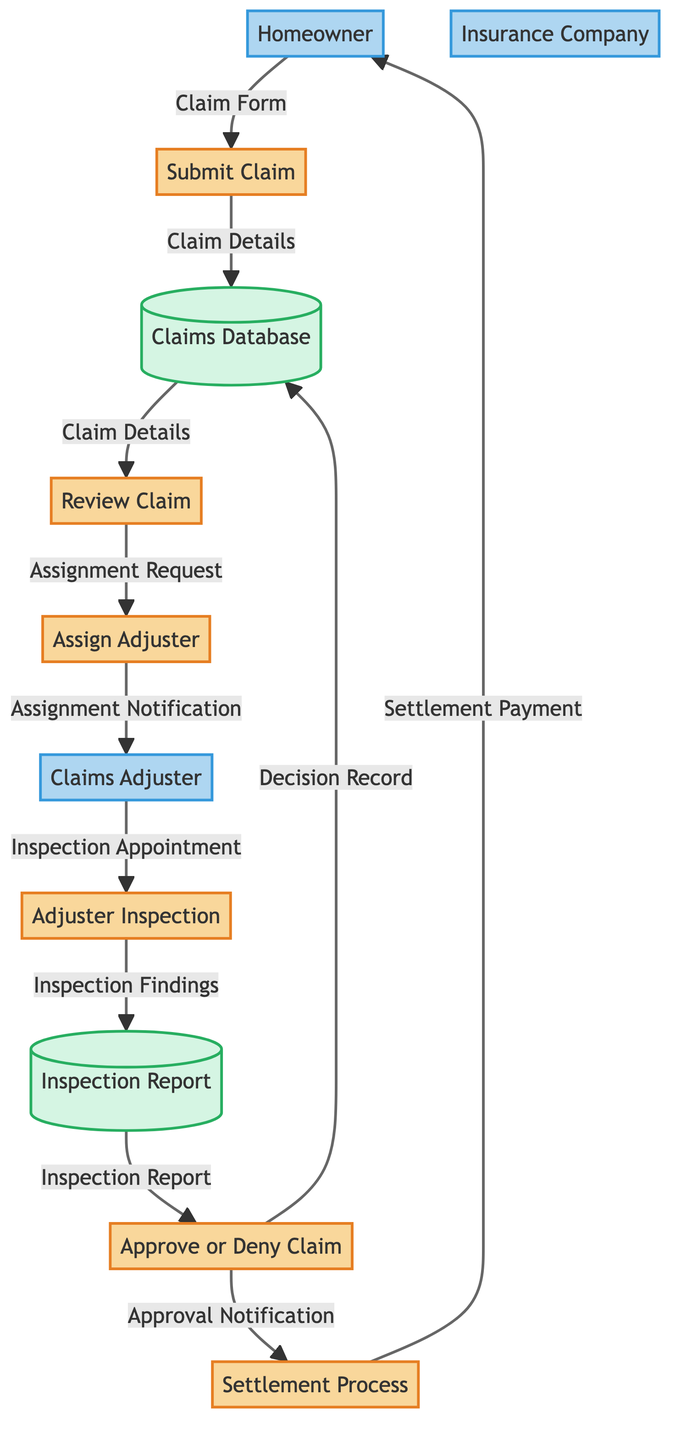What is the first process in the claim process? The diagram indicates that the first process is "Submit Claim," which is where the homeowner initiates the insurance claim.
Answer: Submit Claim How many processes are listed in the diagram? By counting each labeled process node in the diagram, there are a total of six processes present.
Answer: 6 Which entity is responsible for inspecting the property? In the diagram, the "Claims Adjuster" is assigned to inspect the property and assess damages according to the steps outlined.
Answer: Claims Adjuster What data is sent from the "Adjuster Inspection" to the "Inspection Report"? The diagram specifies that the data transferred is "Inspection Findings," which is critical documentation prepared by the adjuster.
Answer: Inspection Findings Which step occurs after the "Review Claim"? Following the "Review Claim," the next step in the process is "Assign Adjuster," as indicated by the flow of data in the diagram.
Answer: Assign Adjuster What happens if a claim is approved? If the claim is approved, the next action is the "Settlement Process," during which the insurance company calculates the settlement amount and issues payment.
Answer: Settlement Process How is the homeowner notified of the settlement payment? According to the diagram, once the "Settlement Process" is completed, a "Settlement Payment" is sent to the homeowner, concluding the claim process.
Answer: Settlement Payment What does the "Claims Database" store? The "Claims Database" is utilized to store various records, particularly "Claim Details" and "Decision Record" related to the submitted claims.
Answer: Claim Details What is the output from "Approve or Deny Claim" if the claim is denied? The output would likely not proceed to the "Settlement Process." Instead, documentation of the denial is recorded, but the claim payment is not issued.
Answer: Denial (implied) Which process involves the homeowner directly? The process that involves direct interaction from the homeowner is "Submit Claim," as it requires the homeowner to fill out and submit the claim form.
Answer: Submit Claim 